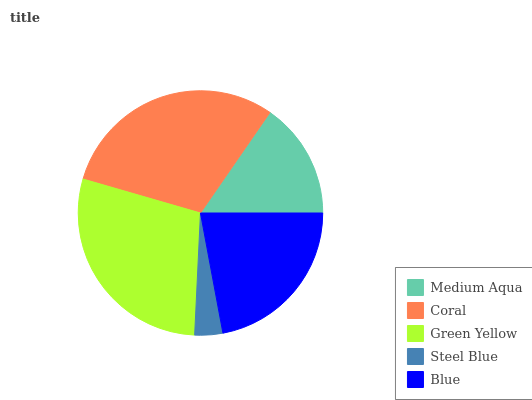Is Steel Blue the minimum?
Answer yes or no. Yes. Is Coral the maximum?
Answer yes or no. Yes. Is Green Yellow the minimum?
Answer yes or no. No. Is Green Yellow the maximum?
Answer yes or no. No. Is Coral greater than Green Yellow?
Answer yes or no. Yes. Is Green Yellow less than Coral?
Answer yes or no. Yes. Is Green Yellow greater than Coral?
Answer yes or no. No. Is Coral less than Green Yellow?
Answer yes or no. No. Is Blue the high median?
Answer yes or no. Yes. Is Blue the low median?
Answer yes or no. Yes. Is Green Yellow the high median?
Answer yes or no. No. Is Green Yellow the low median?
Answer yes or no. No. 